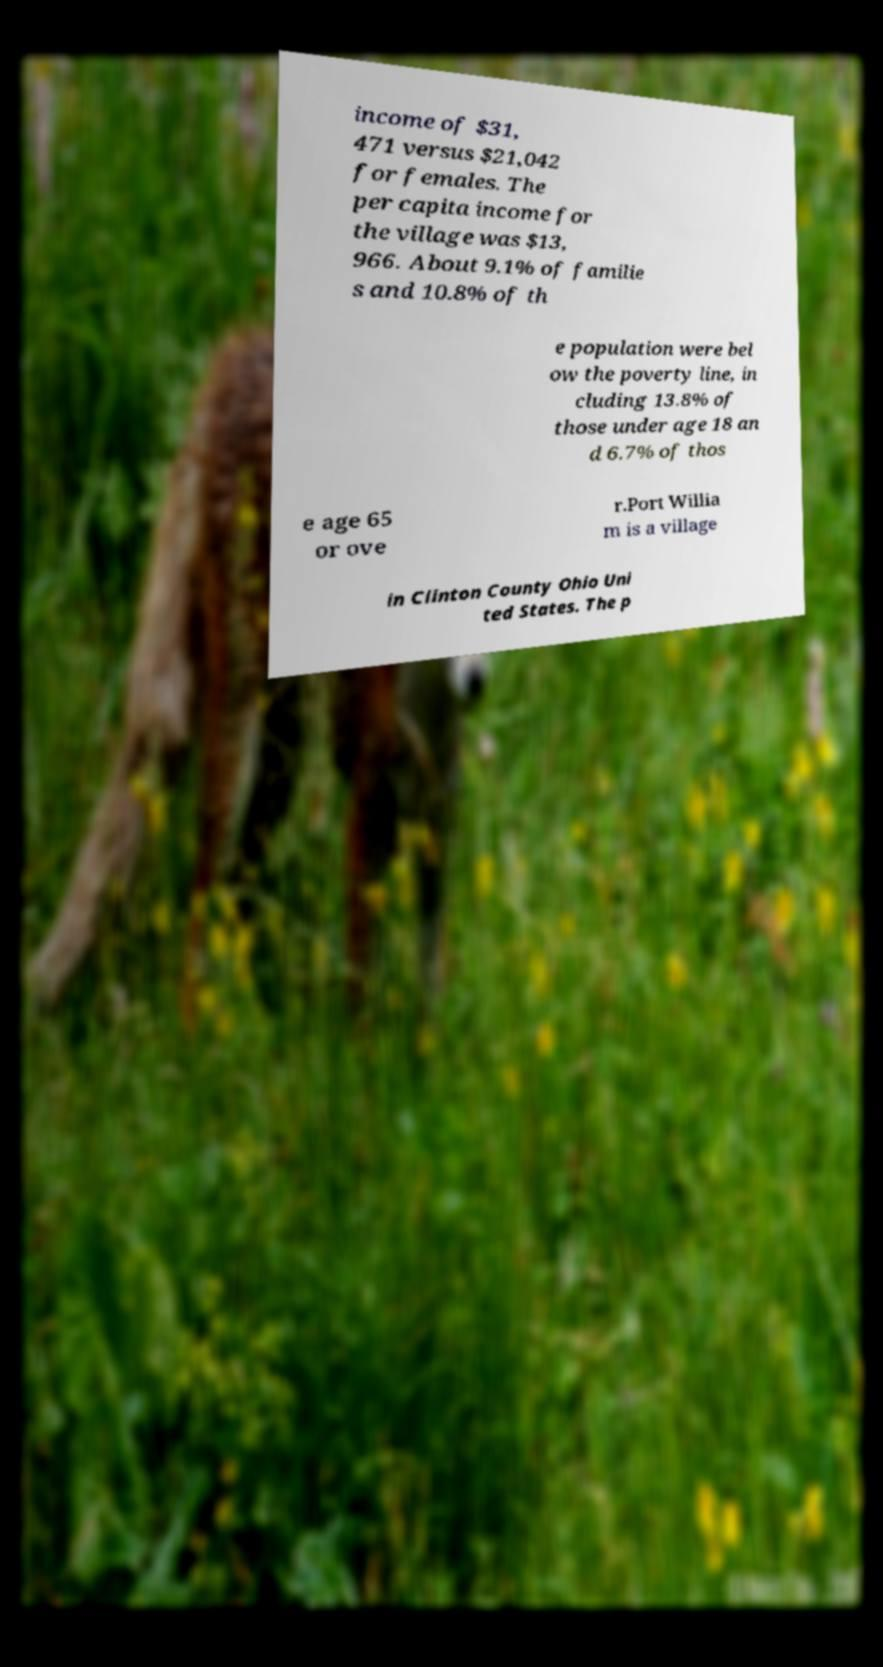Can you accurately transcribe the text from the provided image for me? income of $31, 471 versus $21,042 for females. The per capita income for the village was $13, 966. About 9.1% of familie s and 10.8% of th e population were bel ow the poverty line, in cluding 13.8% of those under age 18 an d 6.7% of thos e age 65 or ove r.Port Willia m is a village in Clinton County Ohio Uni ted States. The p 